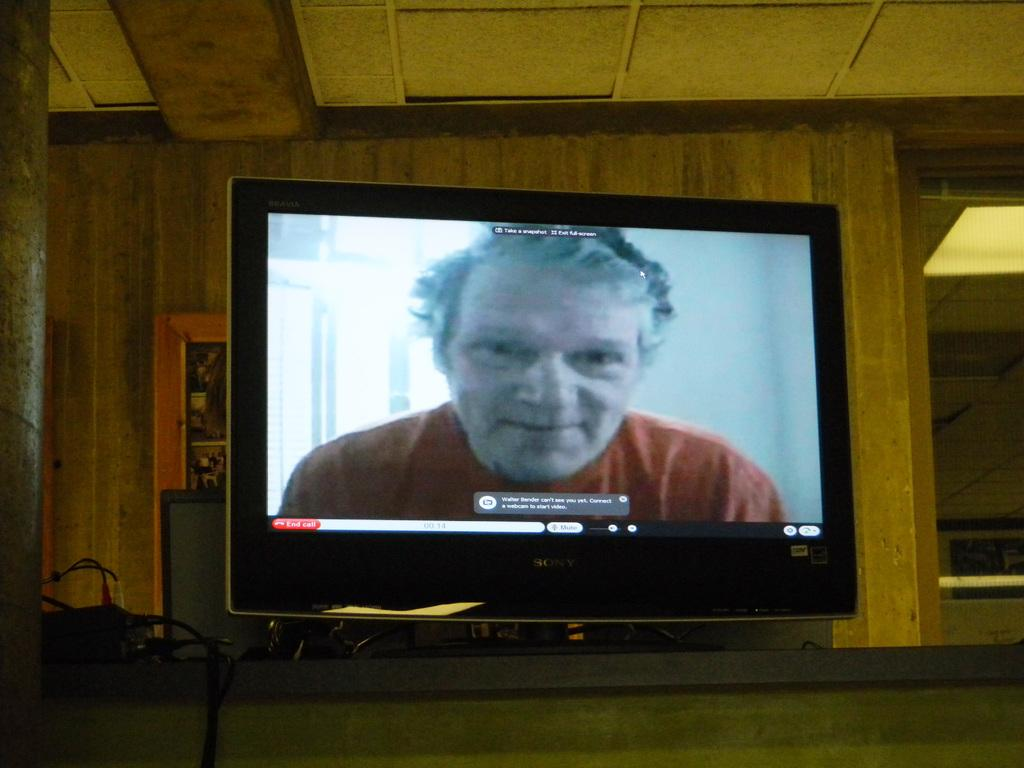<image>
Create a compact narrative representing the image presented. A man wearing red can be seen on a Sony computer monitor 